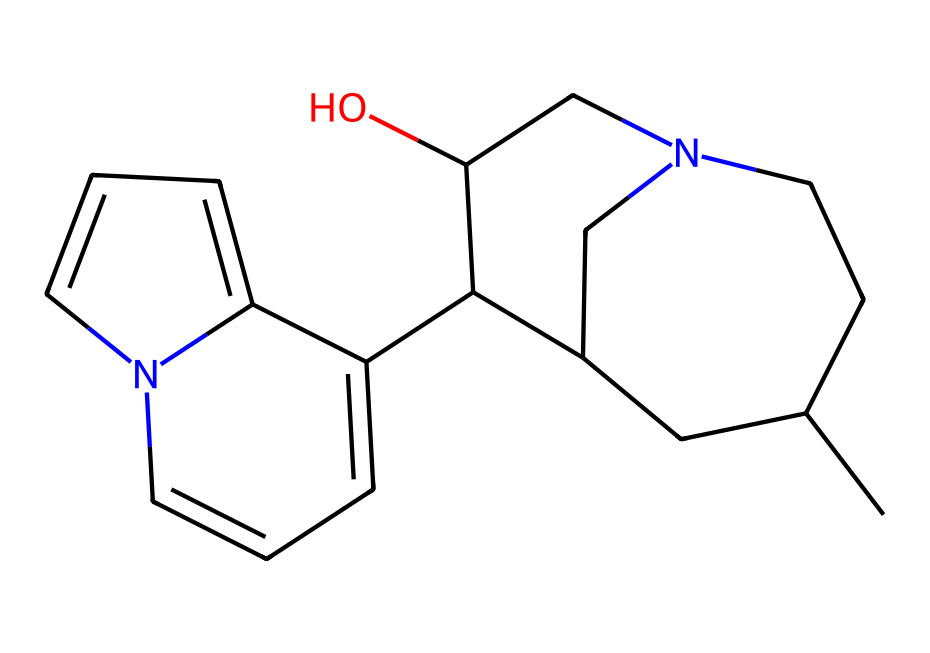What is the molecular formula of quinine? To derive the molecular formula from the SMILES provided, we need to count the number of each type of atom represented. By analyzing the SMILES notation, we can identify the atoms: there are 20 carbon (C) atoms, 24 hydrogen (H) atoms, 1 nitrogen (N) atom, and 1 oxygen (O) atom. Therefore, the molecular formula is C20H24N2O2.
Answer: C20H24N2O2 How many rings are present in quinine's structure? The rings in a chemical structure can be identified through the connections between atoms in the SMILES. In this case, we can observe the presence of two distinct ring systems in the structure of quinine, indicated by the numerical symbols in the SMILES (1, 2, 3, and 4) which show how the atoms are interconnected. Hence, there are two fused cyclohexene rings and a piperidine ring.
Answer: 2 Which type of functional group is present in quinine? We can infer that quinine contains an alcohol functional group as indicated by the presence of an -OH (hydroxyl) group in its structure. In the SMILES, the 'O' directly attached to a carbon atom suggests the presence of this group, characterizing its functional behavior.
Answer: alcohol What atom is primarily responsible for the alkalinity of quinine? The presence of nitrogen atoms (indicated in the SMILES as 'N') is known to contribute to the basicity of compounds, particularly in alkaloids. In quinine, there are two nitrogen atoms that contribute to its alkaline properties. Thus, nitrogen is the contributing element.
Answer: nitrogen What is the role of quinine in medicinal applications? Quinine is primarily recognized for its function as an antimalarial drug, as it has been historically used to treat malaria due to its effectiveness against the Plasmodium parasite. This medicinal property is attributed to its structural characteristics and the ability to interact with certain biological pathways.
Answer: antimalarial Is quinine a naturally occurring alkaloid? Quinine is derived from the bark of the Cinchona tree, which confirms its classification as a naturally occurring alkaloid. This origin combined with its molecular structure confirms its role within traditional medicine settings.
Answer: yes 